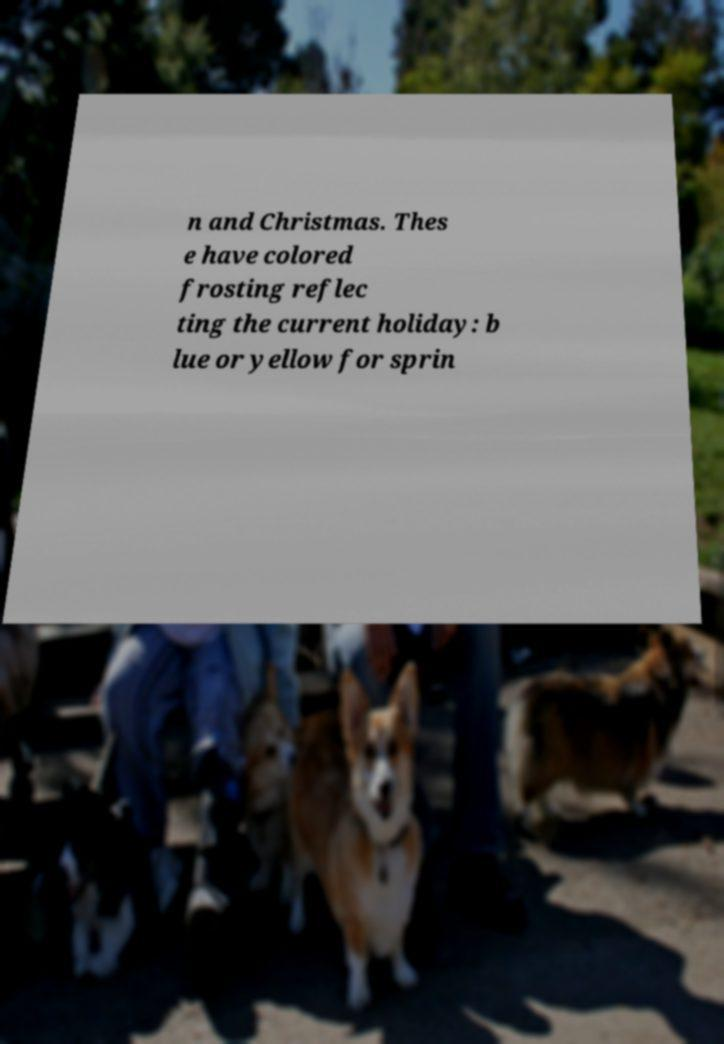Could you extract and type out the text from this image? n and Christmas. Thes e have colored frosting reflec ting the current holiday: b lue or yellow for sprin 